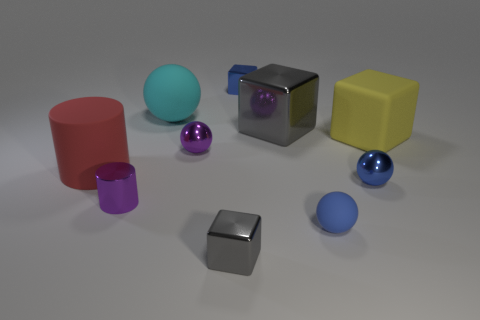What can you infer about the lighting in this scene? The lighting in the scene seems to be diffused with soft shadows, indicating there may be a single broad light source overhead, possibly simulating ambient daylight. There's a lack of harsh shadows, so it's unlikely that direct lighting is used. The reflections on the metallic purple and grey objects suggest the light source is above and slightly to the front of the objects. 